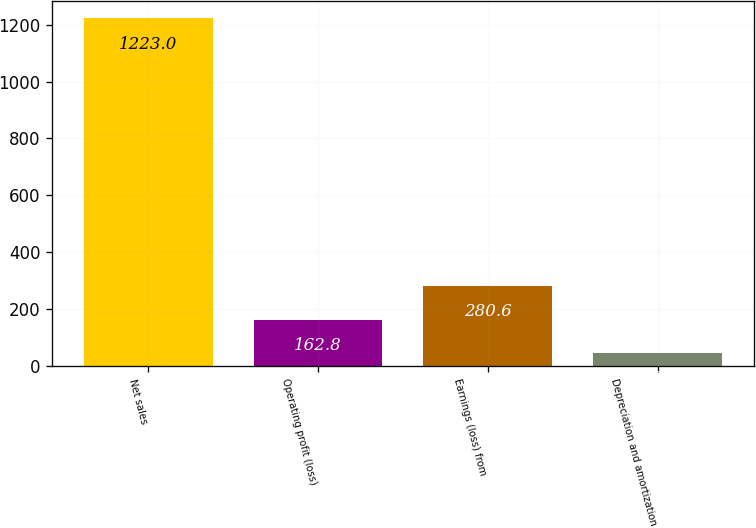<chart> <loc_0><loc_0><loc_500><loc_500><bar_chart><fcel>Net sales<fcel>Operating profit (loss)<fcel>Earnings (loss) from<fcel>Depreciation and amortization<nl><fcel>1223<fcel>162.8<fcel>280.6<fcel>45<nl></chart> 